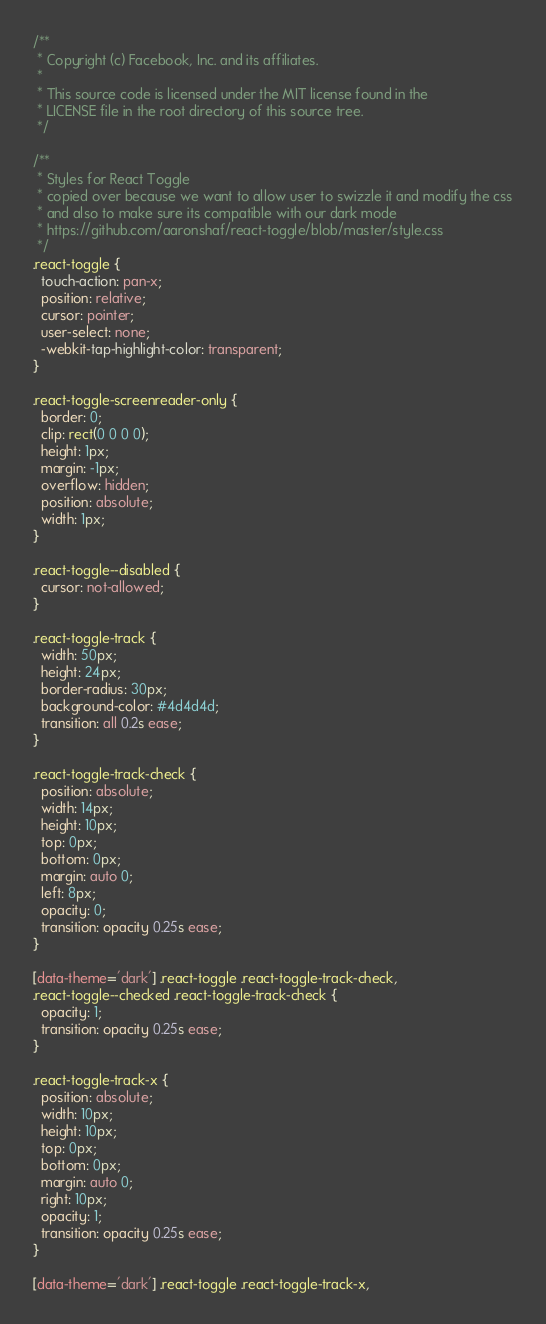<code> <loc_0><loc_0><loc_500><loc_500><_CSS_>/**
 * Copyright (c) Facebook, Inc. and its affiliates.
 *
 * This source code is licensed under the MIT license found in the
 * LICENSE file in the root directory of this source tree.
 */

/**
 * Styles for React Toggle
 * copied over because we want to allow user to swizzle it and modify the css
 * and also to make sure its compatible with our dark mode
 * https://github.com/aaronshaf/react-toggle/blob/master/style.css
 */
.react-toggle {
  touch-action: pan-x;
  position: relative;
  cursor: pointer;
  user-select: none;
  -webkit-tap-highlight-color: transparent;
}

.react-toggle-screenreader-only {
  border: 0;
  clip: rect(0 0 0 0);
  height: 1px;
  margin: -1px;
  overflow: hidden;
  position: absolute;
  width: 1px;
}

.react-toggle--disabled {
  cursor: not-allowed;
}

.react-toggle-track {
  width: 50px;
  height: 24px;
  border-radius: 30px;
  background-color: #4d4d4d;
  transition: all 0.2s ease;
}

.react-toggle-track-check {
  position: absolute;
  width: 14px;
  height: 10px;
  top: 0px;
  bottom: 0px;
  margin: auto 0;
  left: 8px;
  opacity: 0;
  transition: opacity 0.25s ease;
}

[data-theme='dark'] .react-toggle .react-toggle-track-check,
.react-toggle--checked .react-toggle-track-check {
  opacity: 1;
  transition: opacity 0.25s ease;
}

.react-toggle-track-x {
  position: absolute;
  width: 10px;
  height: 10px;
  top: 0px;
  bottom: 0px;
  margin: auto 0;
  right: 10px;
  opacity: 1;
  transition: opacity 0.25s ease;
}

[data-theme='dark'] .react-toggle .react-toggle-track-x,</code> 